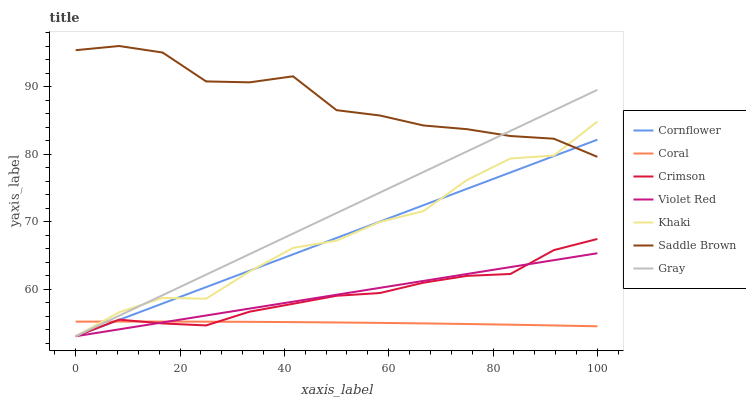Does Coral have the minimum area under the curve?
Answer yes or no. Yes. Does Saddle Brown have the maximum area under the curve?
Answer yes or no. Yes. Does Violet Red have the minimum area under the curve?
Answer yes or no. No. Does Violet Red have the maximum area under the curve?
Answer yes or no. No. Is Violet Red the smoothest?
Answer yes or no. Yes. Is Khaki the roughest?
Answer yes or no. Yes. Is Khaki the smoothest?
Answer yes or no. No. Is Violet Red the roughest?
Answer yes or no. No. Does Cornflower have the lowest value?
Answer yes or no. Yes. Does Coral have the lowest value?
Answer yes or no. No. Does Saddle Brown have the highest value?
Answer yes or no. Yes. Does Violet Red have the highest value?
Answer yes or no. No. Is Crimson less than Saddle Brown?
Answer yes or no. Yes. Is Saddle Brown greater than Coral?
Answer yes or no. Yes. Does Khaki intersect Crimson?
Answer yes or no. Yes. Is Khaki less than Crimson?
Answer yes or no. No. Is Khaki greater than Crimson?
Answer yes or no. No. Does Crimson intersect Saddle Brown?
Answer yes or no. No. 